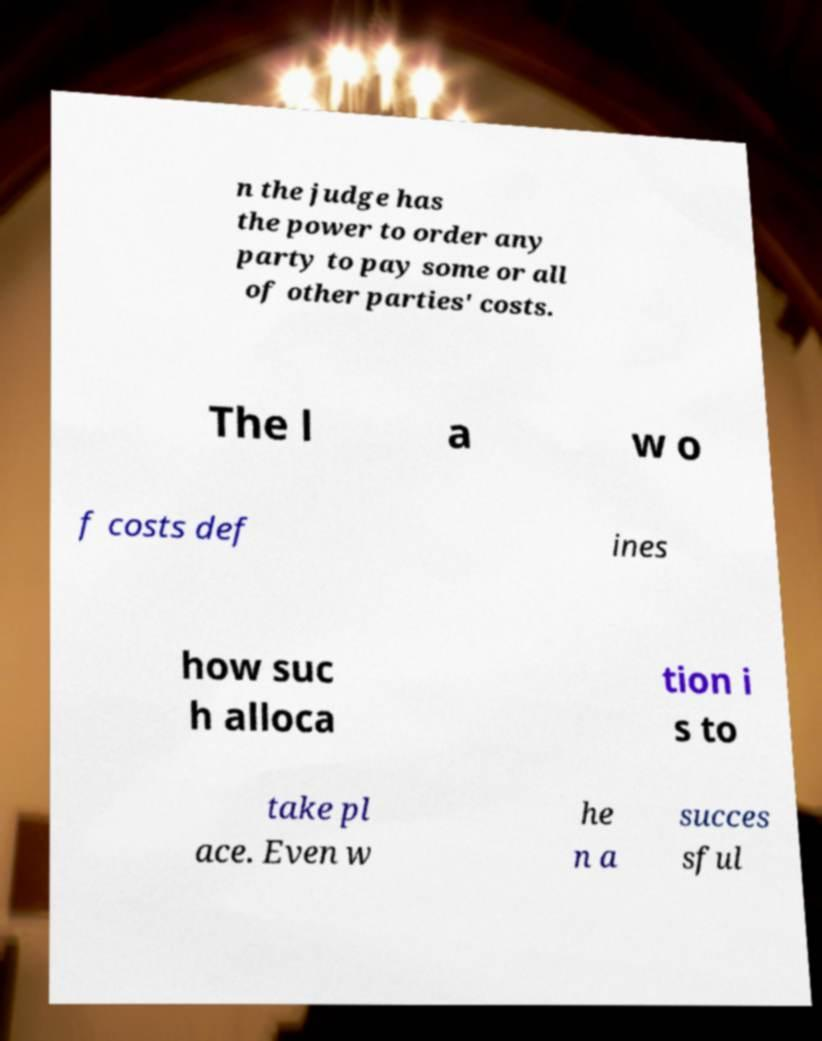Could you assist in decoding the text presented in this image and type it out clearly? n the judge has the power to order any party to pay some or all of other parties' costs. The l a w o f costs def ines how suc h alloca tion i s to take pl ace. Even w he n a succes sful 